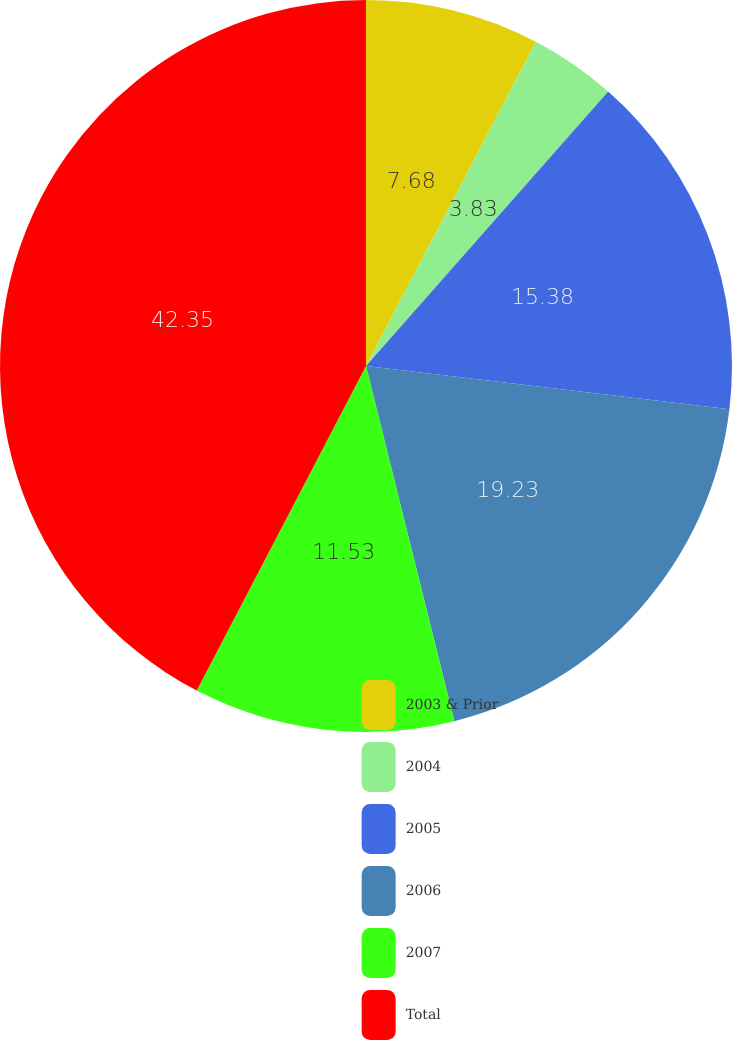Convert chart to OTSL. <chart><loc_0><loc_0><loc_500><loc_500><pie_chart><fcel>2003 & Prior<fcel>2004<fcel>2005<fcel>2006<fcel>2007<fcel>Total<nl><fcel>7.68%<fcel>3.83%<fcel>15.38%<fcel>19.23%<fcel>11.53%<fcel>42.35%<nl></chart> 